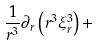Convert formula to latex. <formula><loc_0><loc_0><loc_500><loc_500>\frac { 1 } { r ^ { 3 } } \partial _ { r } \left ( r ^ { 3 } \xi _ { r } ^ { 3 } \right ) +</formula> 